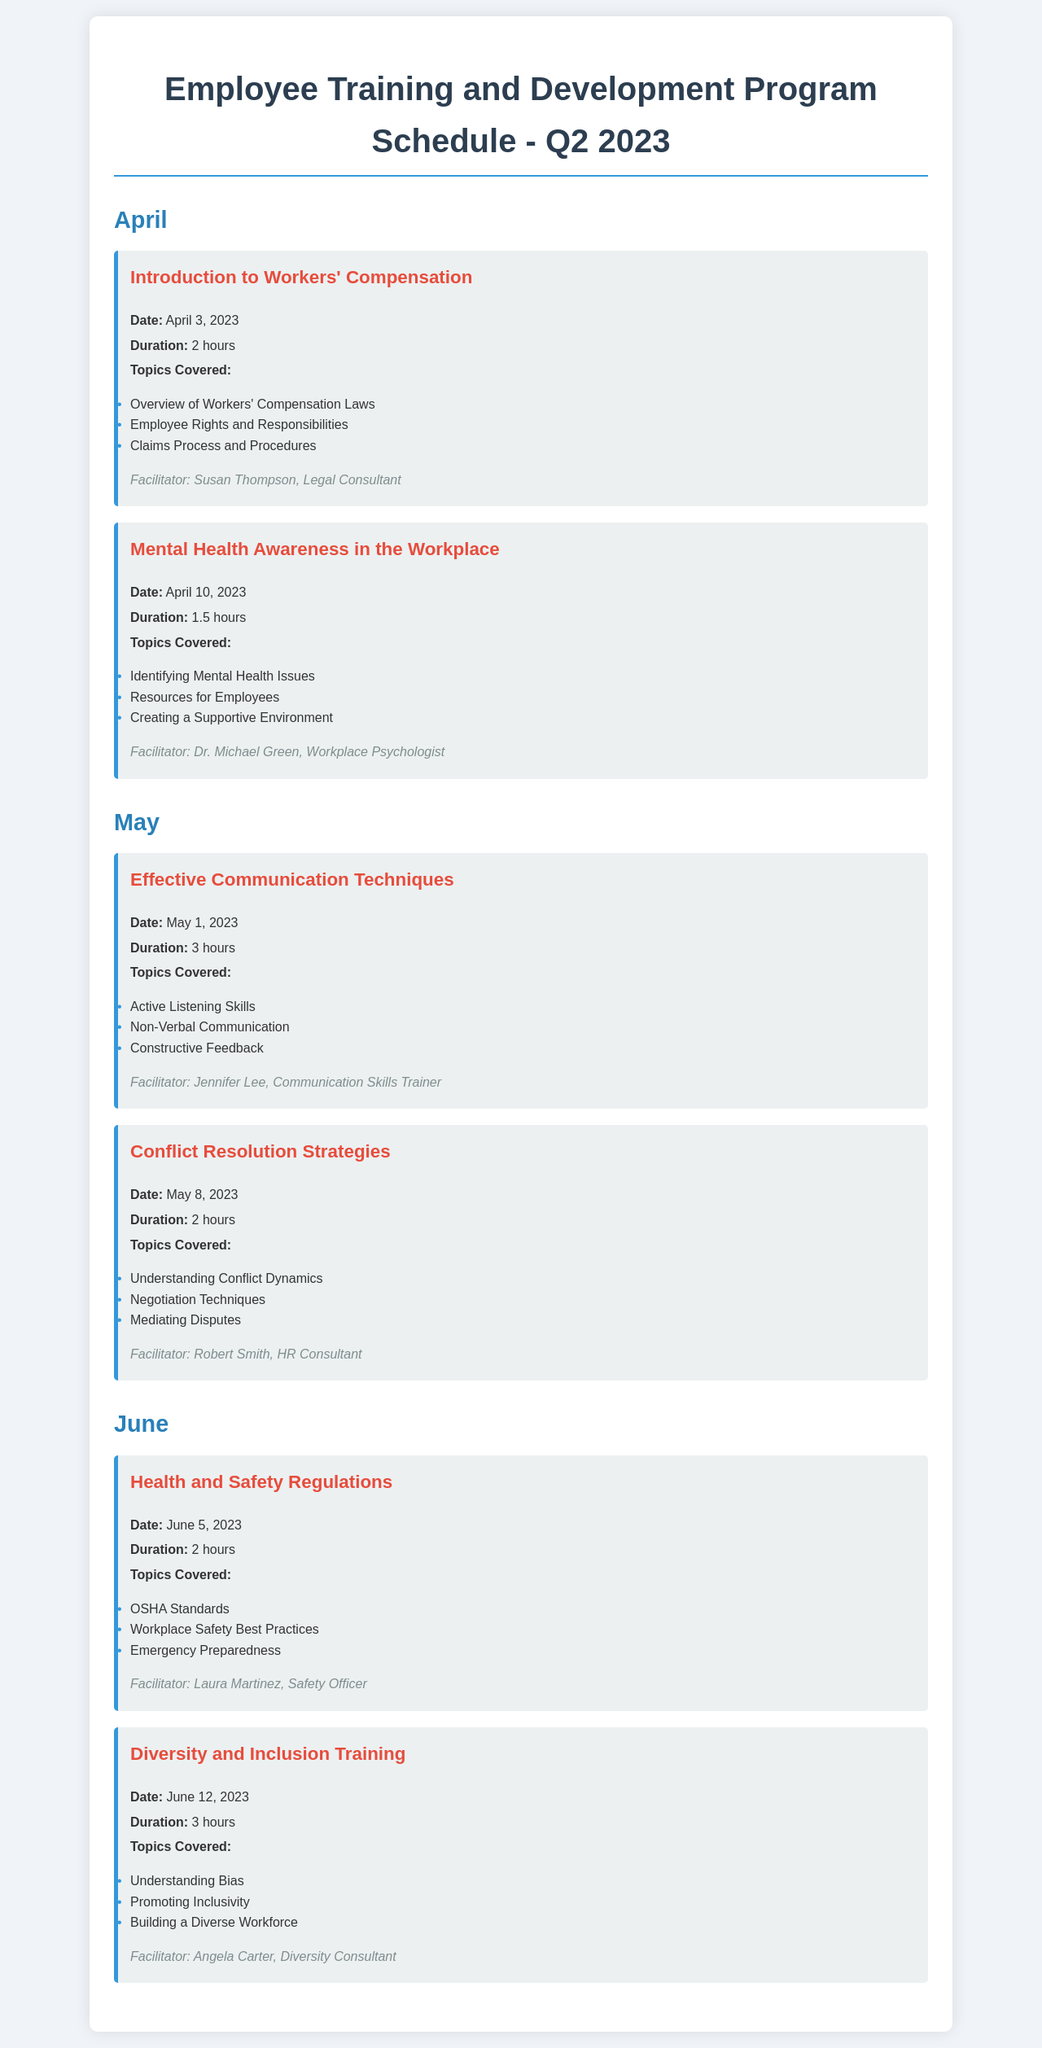What is the duration of the "Introduction to Workers' Compensation" session? The duration of the session is stated in the document as 2 hours.
Answer: 2 hours Who is the facilitator for the "Mental Health Awareness in the Workplace" session? The facilitator's name is mentioned in the document, and it is Dr. Michael Green.
Answer: Dr. Michael Green When is the "Effective Communication Techniques" session scheduled? The date of the session is provided in the document as May 1, 2023.
Answer: May 1, 2023 What are the topics covered in the "Diversity and Inclusion Training"? The document lists the three topics covered in this session.
Answer: Understanding Bias, Promoting Inclusivity, Building a Diverse Workforce How long is the "Health and Safety Regulations" session? The duration is specified in the document, which indicates that it is 2 hours.
Answer: 2 hours Which month has the session on "Conflict Resolution Strategies"? The document clearly states that this session is in May.
Answer: May What type of training is scheduled for June 12, 2023? The document indicates that this date is for Diversity and Inclusion Training.
Answer: Diversity and Inclusion Training How many hours is the "Mental Health Awareness in the Workplace" session? The document specifies the duration of the session as 1.5 hours.
Answer: 1.5 hours What is the main focus of the "Introduction to Workers' Compensation" session? The topics covered in the session indicate the focus is on Workers' Compensation Laws.
Answer: Workers' Compensation Laws 